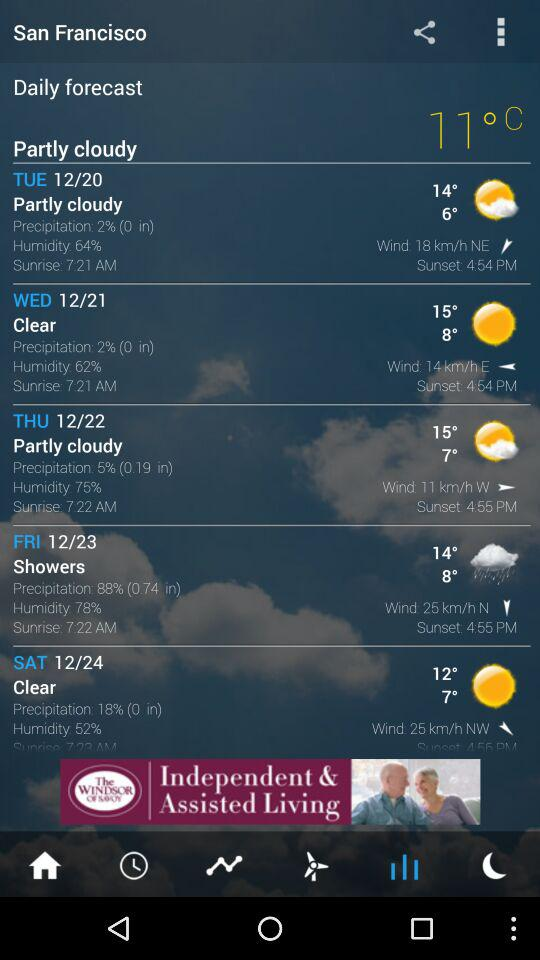Will it rain on Friday?
When the provided information is insufficient, respond with <no answer>. <no answer> 